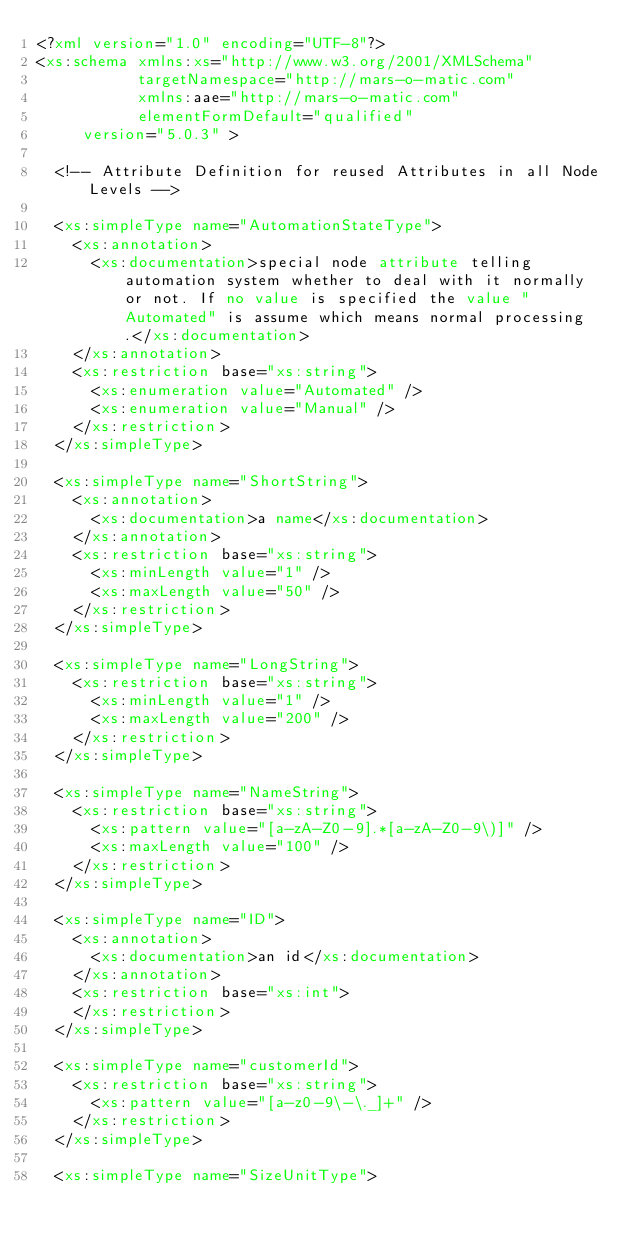<code> <loc_0><loc_0><loc_500><loc_500><_XML_><?xml version="1.0" encoding="UTF-8"?>
<xs:schema xmlns:xs="http://www.w3.org/2001/XMLSchema"
           targetNamespace="http://mars-o-matic.com" 
           xmlns:aae="http://mars-o-matic.com"
           elementFormDefault="qualified"
	   version="5.0.3" >

  <!-- Attribute Definition for reused Attributes in all Node Levels -->

  <xs:simpleType name="AutomationStateType">
    <xs:annotation>
      <xs:documentation>special node attribute telling automation system whether to deal with it normally or not. If no value is specified the value "Automated" is assume which means normal processing.</xs:documentation>
    </xs:annotation>
    <xs:restriction base="xs:string">
      <xs:enumeration value="Automated" />
      <xs:enumeration value="Manual" />
    </xs:restriction>
  </xs:simpleType>

  <xs:simpleType name="ShortString">
    <xs:annotation>
      <xs:documentation>a name</xs:documentation>
    </xs:annotation>
    <xs:restriction base="xs:string">
      <xs:minLength value="1" />
      <xs:maxLength value="50" />
    </xs:restriction>
  </xs:simpleType>

  <xs:simpleType name="LongString">
    <xs:restriction base="xs:string">
      <xs:minLength value="1" />
      <xs:maxLength value="200" />
    </xs:restriction>
  </xs:simpleType>

  <xs:simpleType name="NameString">
    <xs:restriction base="xs:string">
      <xs:pattern value="[a-zA-Z0-9].*[a-zA-Z0-9\)]" />
      <xs:maxLength value="100" />
    </xs:restriction>
  </xs:simpleType>

  <xs:simpleType name="ID">
    <xs:annotation>
      <xs:documentation>an id</xs:documentation>
    </xs:annotation>
    <xs:restriction base="xs:int">
    </xs:restriction>
  </xs:simpleType>

  <xs:simpleType name="customerId">
    <xs:restriction base="xs:string">
      <xs:pattern value="[a-z0-9\-\._]+" />
    </xs:restriction>
  </xs:simpleType>

  <xs:simpleType name="SizeUnitType"></code> 